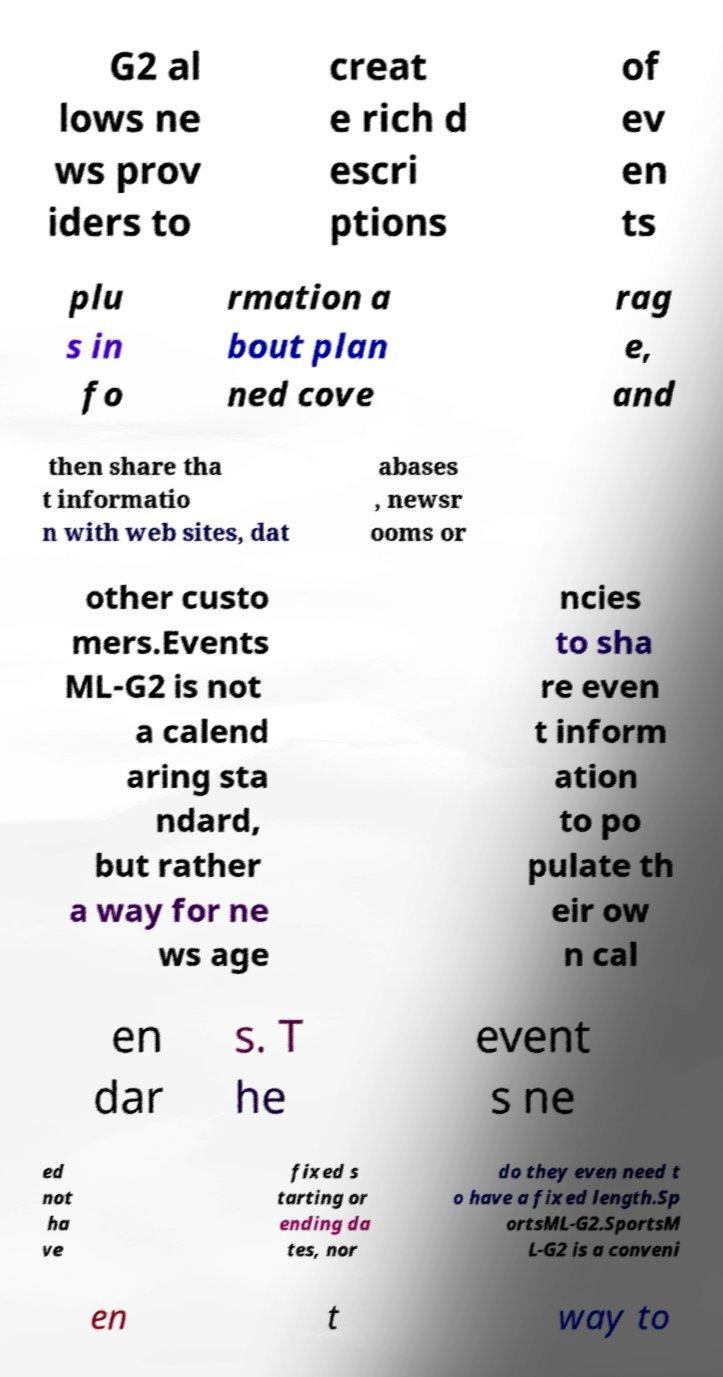Please read and relay the text visible in this image. What does it say? G2 al lows ne ws prov iders to creat e rich d escri ptions of ev en ts plu s in fo rmation a bout plan ned cove rag e, and then share tha t informatio n with web sites, dat abases , newsr ooms or other custo mers.Events ML-G2 is not a calend aring sta ndard, but rather a way for ne ws age ncies to sha re even t inform ation to po pulate th eir ow n cal en dar s. T he event s ne ed not ha ve fixed s tarting or ending da tes, nor do they even need t o have a fixed length.Sp ortsML-G2.SportsM L-G2 is a conveni en t way to 